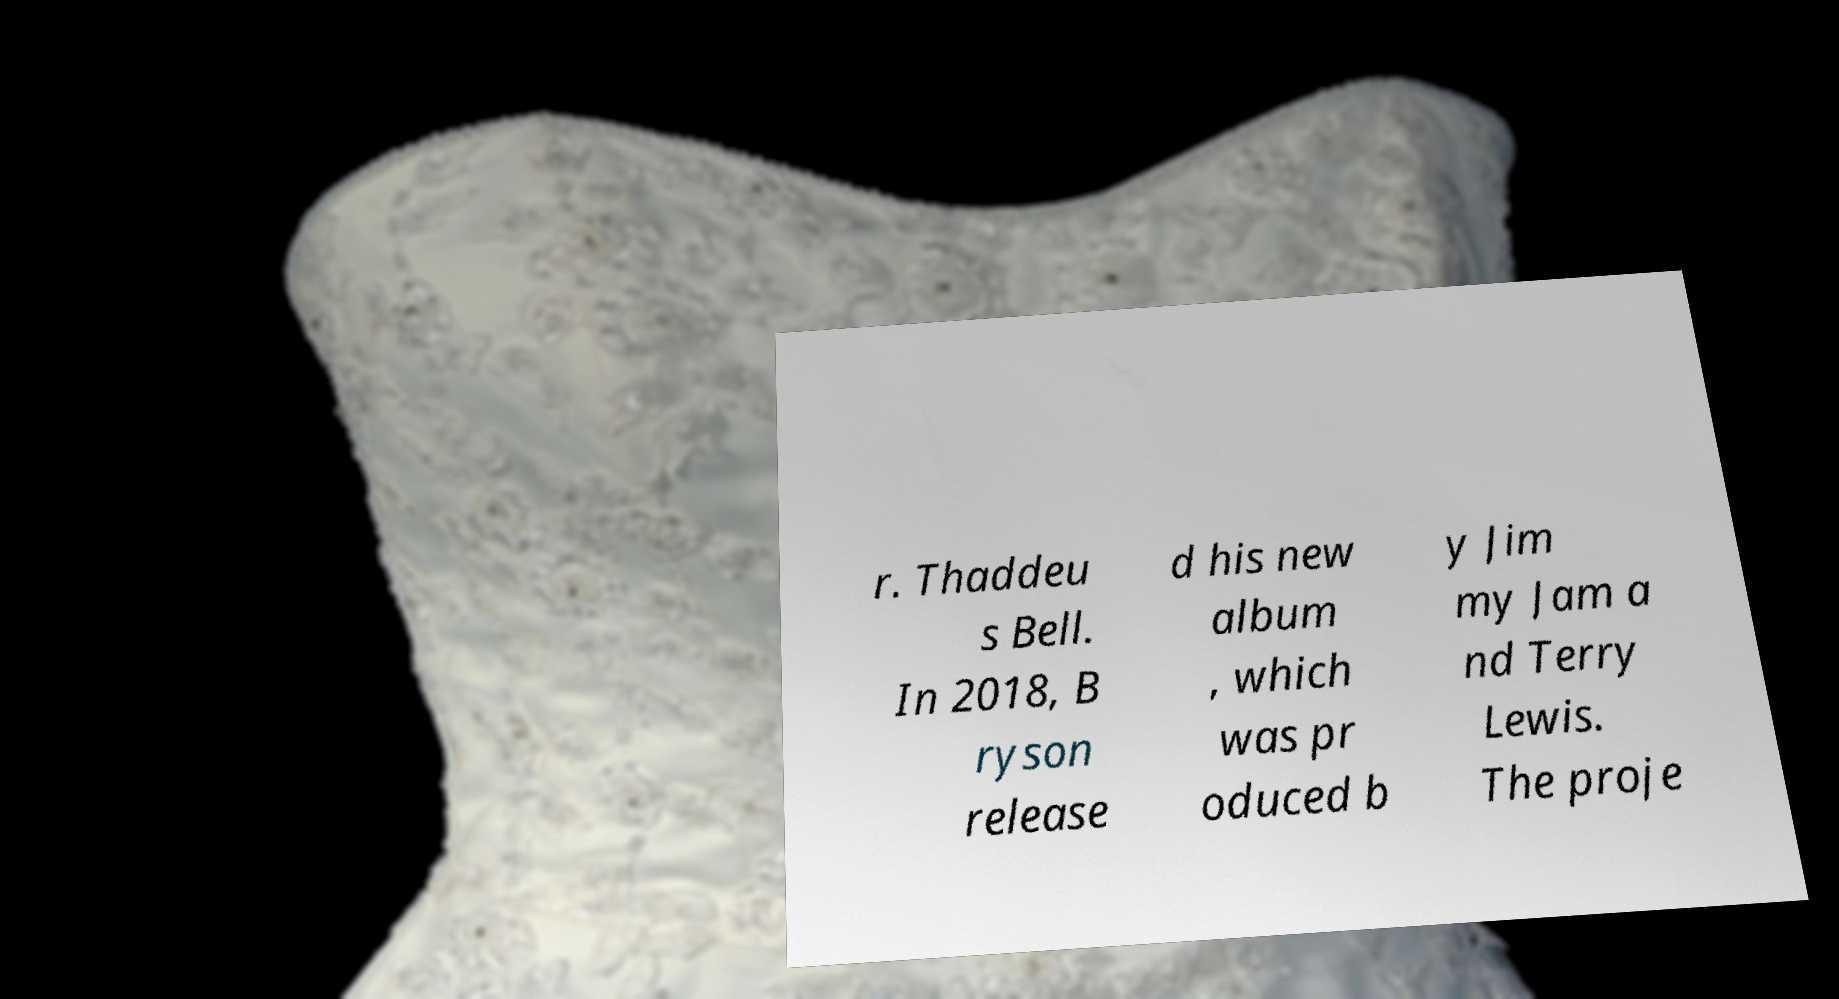Please read and relay the text visible in this image. What does it say? r. Thaddeu s Bell. In 2018, B ryson release d his new album , which was pr oduced b y Jim my Jam a nd Terry Lewis. The proje 